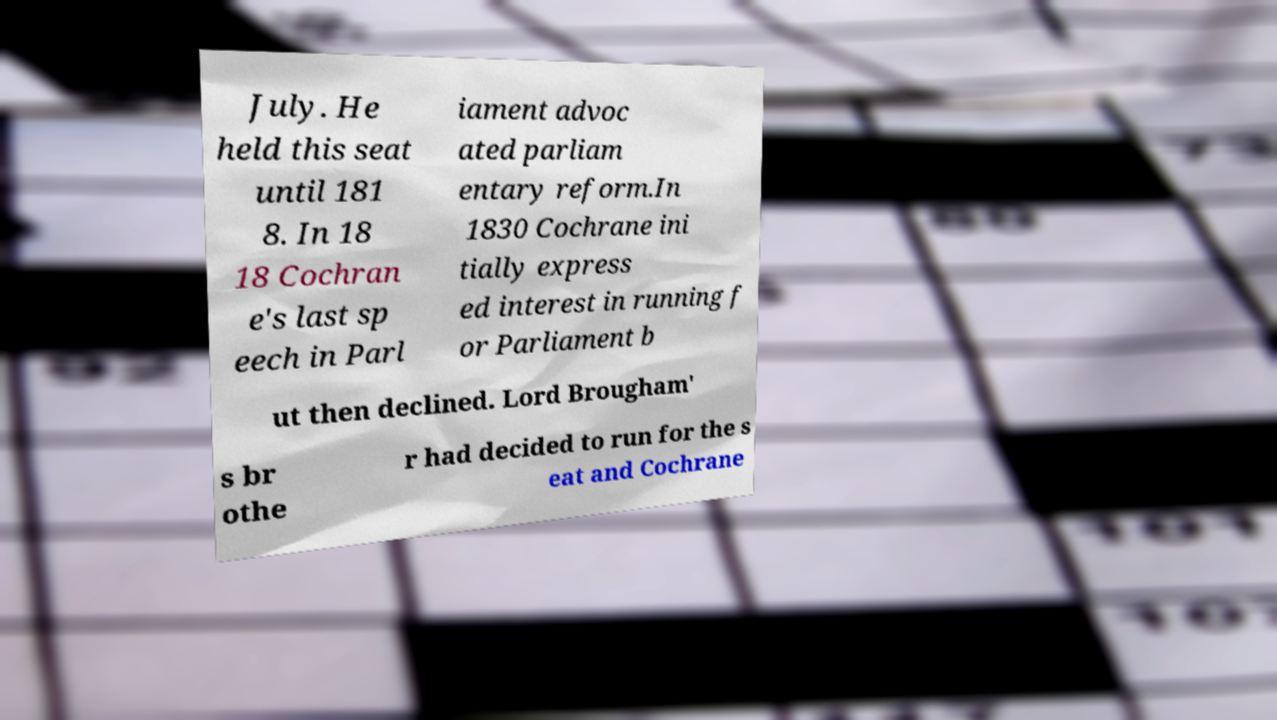There's text embedded in this image that I need extracted. Can you transcribe it verbatim? July. He held this seat until 181 8. In 18 18 Cochran e's last sp eech in Parl iament advoc ated parliam entary reform.In 1830 Cochrane ini tially express ed interest in running f or Parliament b ut then declined. Lord Brougham' s br othe r had decided to run for the s eat and Cochrane 